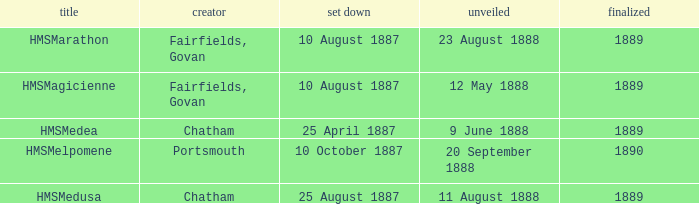Can you parse all the data within this table? {'header': ['title', 'creator', 'set down', 'unveiled', 'finalized'], 'rows': [['HMSMarathon', 'Fairfields, Govan', '10 August 1887', '23 August 1888', '1889'], ['HMSMagicienne', 'Fairfields, Govan', '10 August 1887', '12 May 1888', '1889'], ['HMSMedea', 'Chatham', '25 April 1887', '9 June 1888', '1889'], ['HMSMelpomene', 'Portsmouth', '10 October 1887', '20 September 1888', '1890'], ['HMSMedusa', 'Chatham', '25 August 1887', '11 August 1888', '1889']]} What is the name of the boat that was built by Chatham and Laid down of 25 april 1887? HMSMedea. 